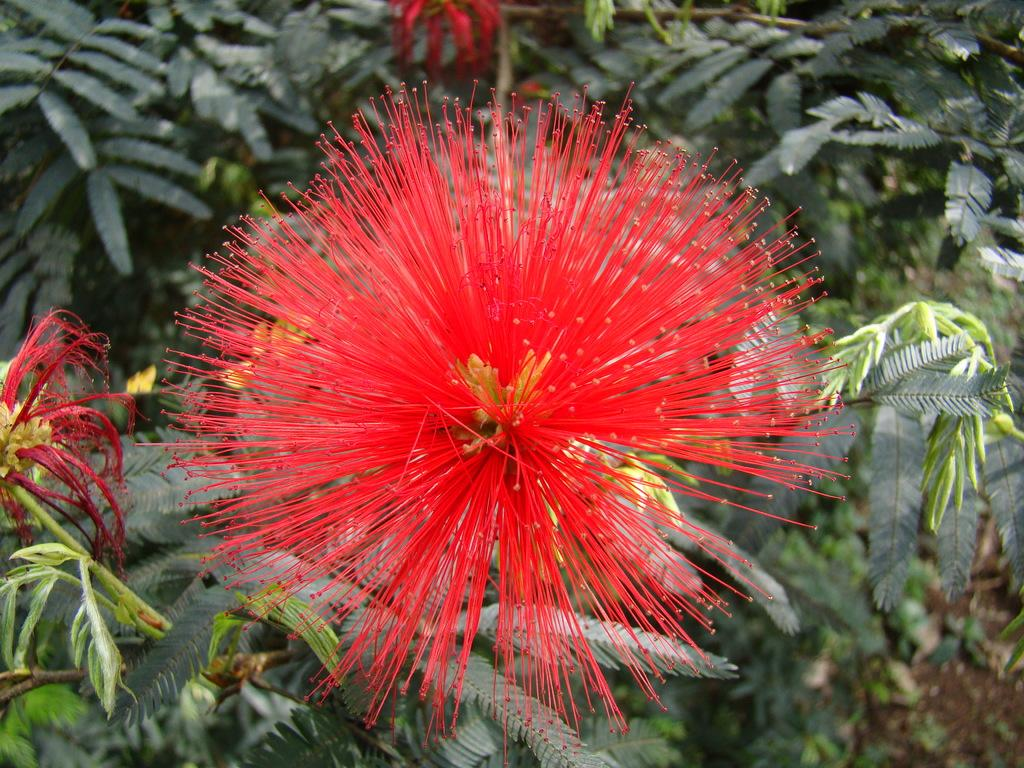What type of living organisms can be seen in the image? Flowers and plants are visible in the image. Can you describe the plants in the image? The plants in the image are not specified, but they are present alongside the flowers. What type of airplane can be seen flying over the flowers in the image? There is no airplane present in the image; it only features flowers and plants. How many pigs are visible among the flowers in the image? There are no pigs present in the image; it only features flowers and plants. 